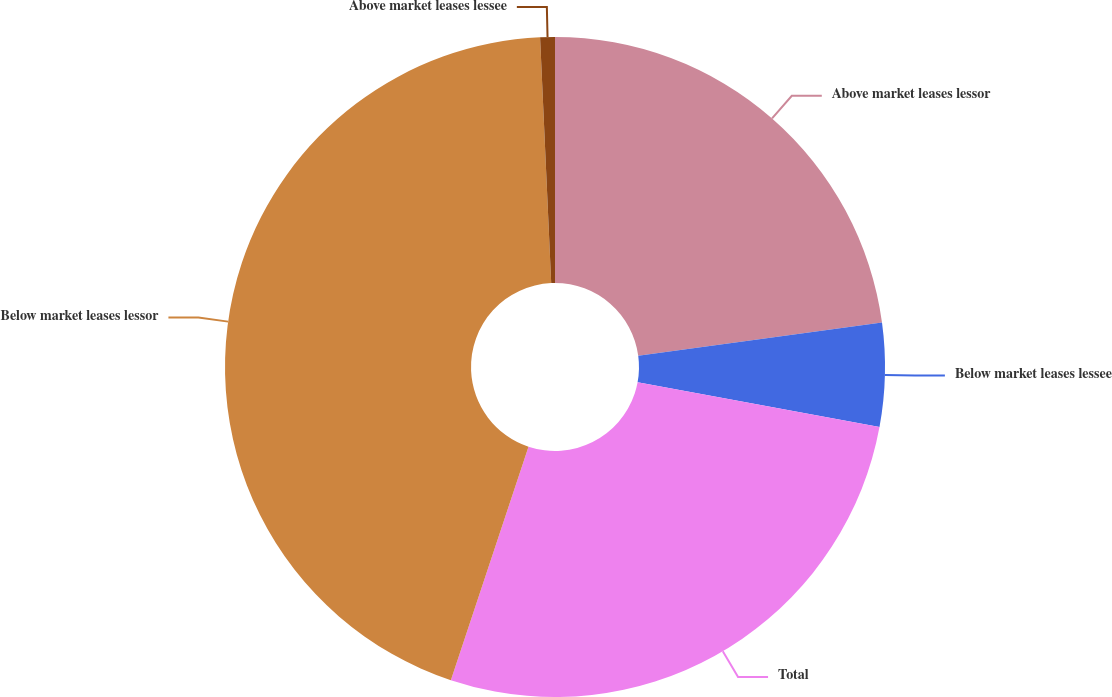Convert chart to OTSL. <chart><loc_0><loc_0><loc_500><loc_500><pie_chart><fcel>Above market leases lessor<fcel>Below market leases lessee<fcel>Total<fcel>Below market leases lessor<fcel>Above market leases lessee<nl><fcel>22.85%<fcel>5.06%<fcel>27.2%<fcel>44.17%<fcel>0.72%<nl></chart> 